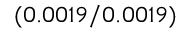<formula> <loc_0><loc_0><loc_500><loc_500>( 0 . 0 0 1 9 / 0 . 0 0 1 9 )</formula> 